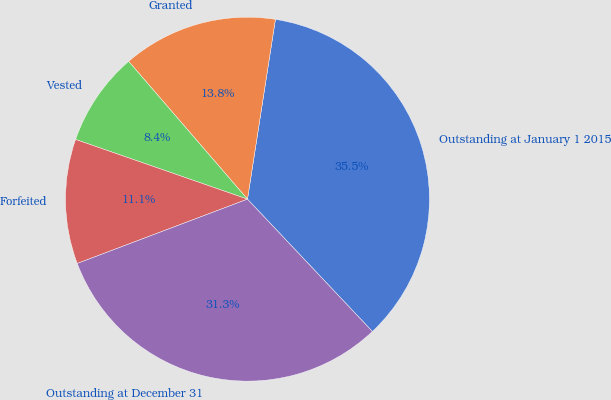Convert chart to OTSL. <chart><loc_0><loc_0><loc_500><loc_500><pie_chart><fcel>Outstanding at January 1 2015<fcel>Granted<fcel>Vested<fcel>Forfeited<fcel>Outstanding at December 31<nl><fcel>35.5%<fcel>13.78%<fcel>8.35%<fcel>11.07%<fcel>31.29%<nl></chart> 